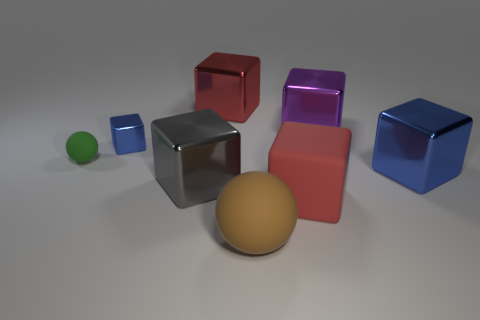What is the material of the large object that is the same color as the small shiny object?
Keep it short and to the point. Metal. What is the color of the sphere left of the red shiny object?
Your answer should be compact. Green. Is the brown object the same size as the green matte ball?
Keep it short and to the point. No. The brown rubber object is what size?
Provide a succinct answer. Large. Is the number of big brown matte things greater than the number of red objects?
Keep it short and to the point. No. What color is the small thing left of the blue metallic cube to the left of the big red object on the right side of the brown thing?
Make the answer very short. Green. There is a large rubber object that is in front of the large red matte object; is its shape the same as the small blue metallic thing?
Give a very brief answer. No. The rubber block that is the same size as the brown object is what color?
Make the answer very short. Red. What number of gray shiny cubes are there?
Provide a short and direct response. 1. Are the large object that is in front of the large matte cube and the big blue thing made of the same material?
Your answer should be compact. No. 